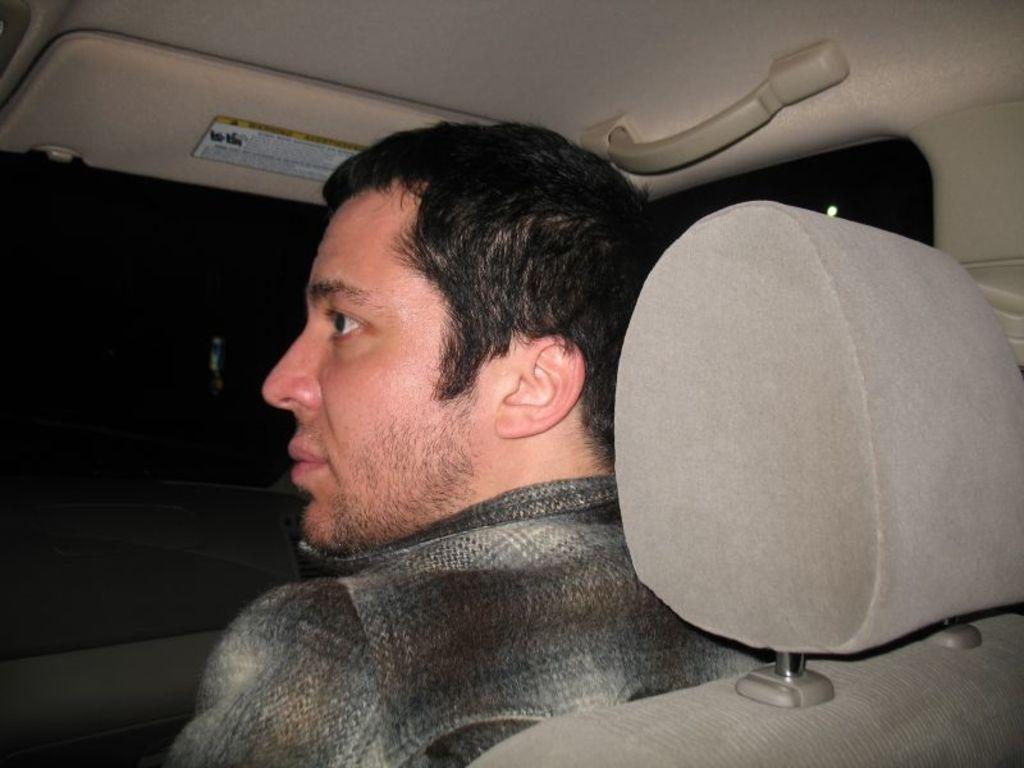Could you give a brief overview of what you see in this image? In this image we can see a man is sitting on the car seat. He is wearing shirt. 